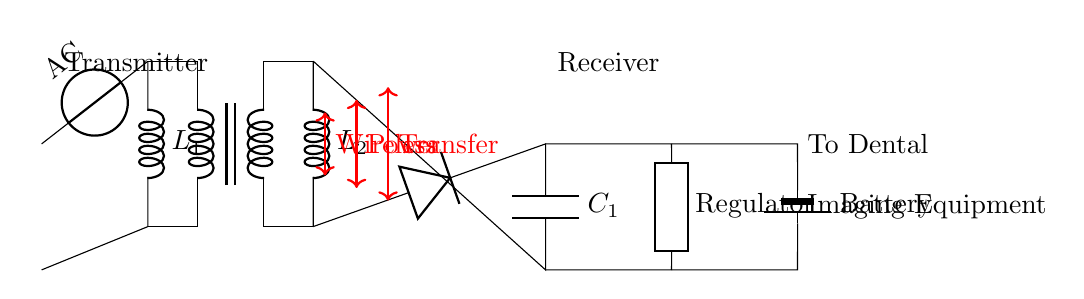What is the type of source in this circuit? The circuit contains an AC voltage source, as indicated by the symbol labeled "AC" connected to the transformer.
Answer: AC How many inductors are present in the circuit? There are two inductors shown in the circuit; they are labeled as L1 and L2 associated with the transformer.
Answer: Two What component is used for rectification in the circuit? A diode is used for rectification, which converts the alternating current to direct current in the circuit.
Answer: Diode What is the purpose of the capacitor labeled C1? The capacitor C1 is used for smoothing the output voltage after rectification by filtering the ripple from the rectified current.
Answer: Smoothing Which component regulates the output voltage? A voltage regulator is included in the circuit diagram to ensure that the output voltage remains constant.
Answer: Regulator What type of power transfer is illustrated in this circuit? The circuit demonstrates wireless power transfer, as indicated by the arrows and labels describing the power transfer mechanism between the transmitter and receiver.
Answer: Wireless What is the final destination of the power in this circuit? The final destination of the power is the dental imaging equipment, indicated by the battery symbol connected to the output section of the circuit.
Answer: Dental Imaging Equipment 